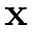Convert formula to latex. <formula><loc_0><loc_0><loc_500><loc_500>x</formula> 